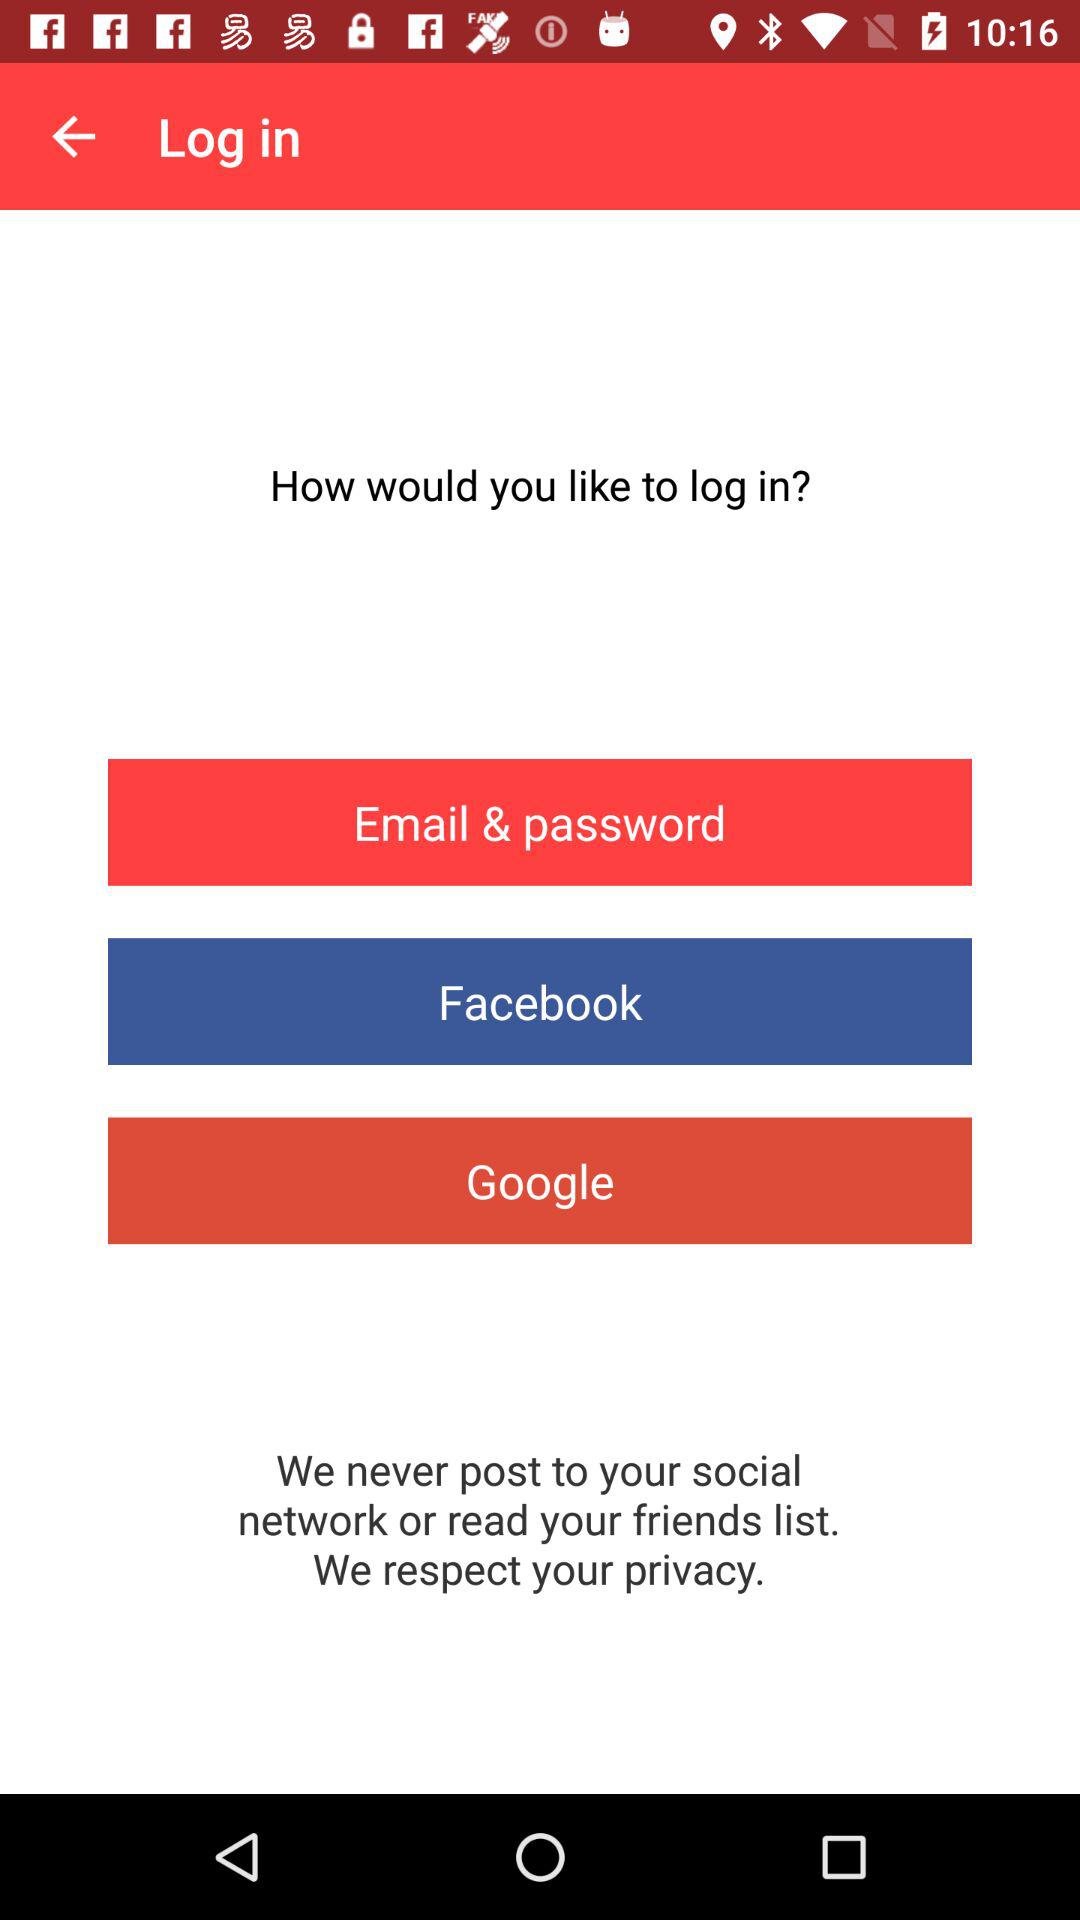Which are the different login options? The different login options are "Email & password", "Facebook" and "Google". 